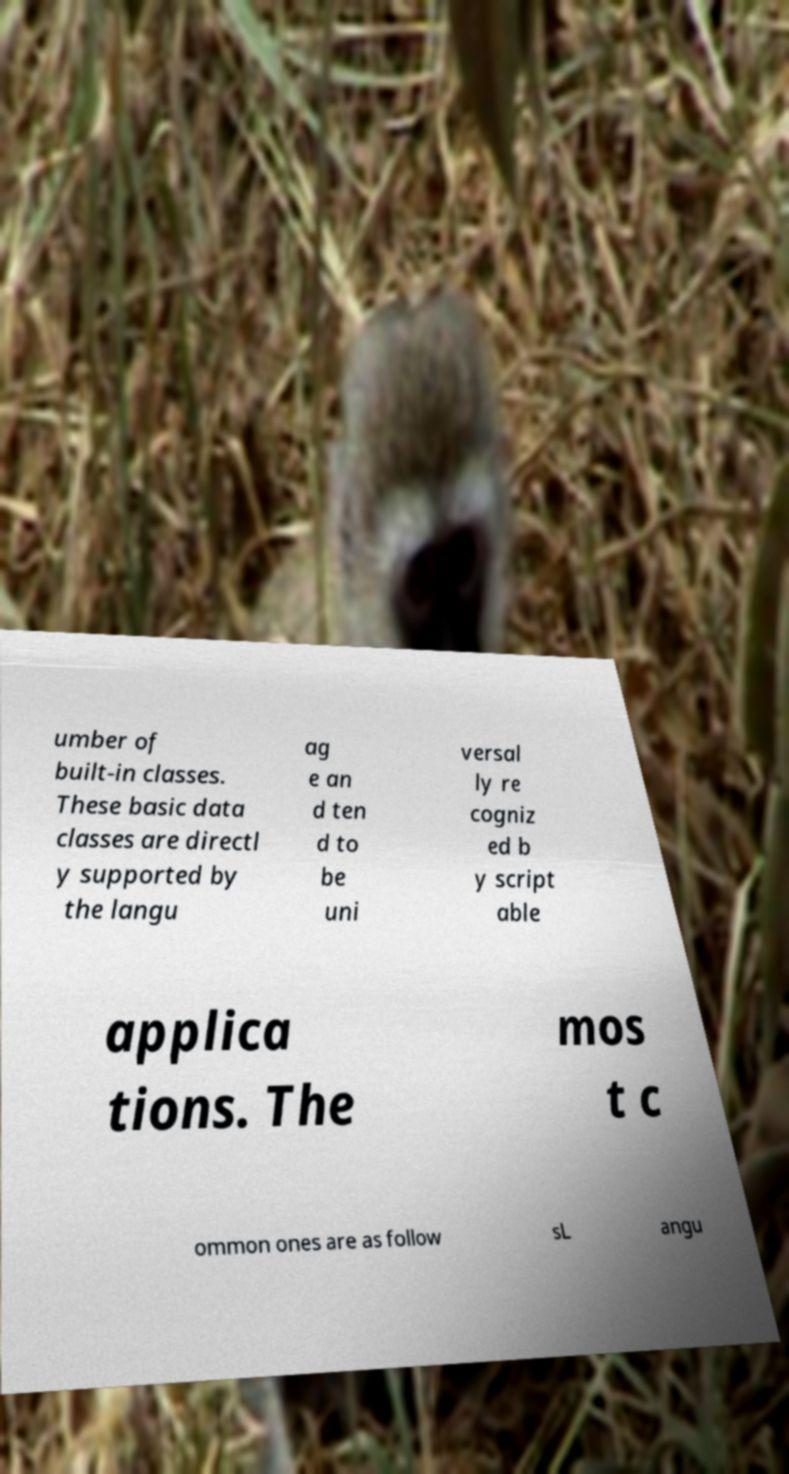There's text embedded in this image that I need extracted. Can you transcribe it verbatim? umber of built-in classes. These basic data classes are directl y supported by the langu ag e an d ten d to be uni versal ly re cogniz ed b y script able applica tions. The mos t c ommon ones are as follow sL angu 